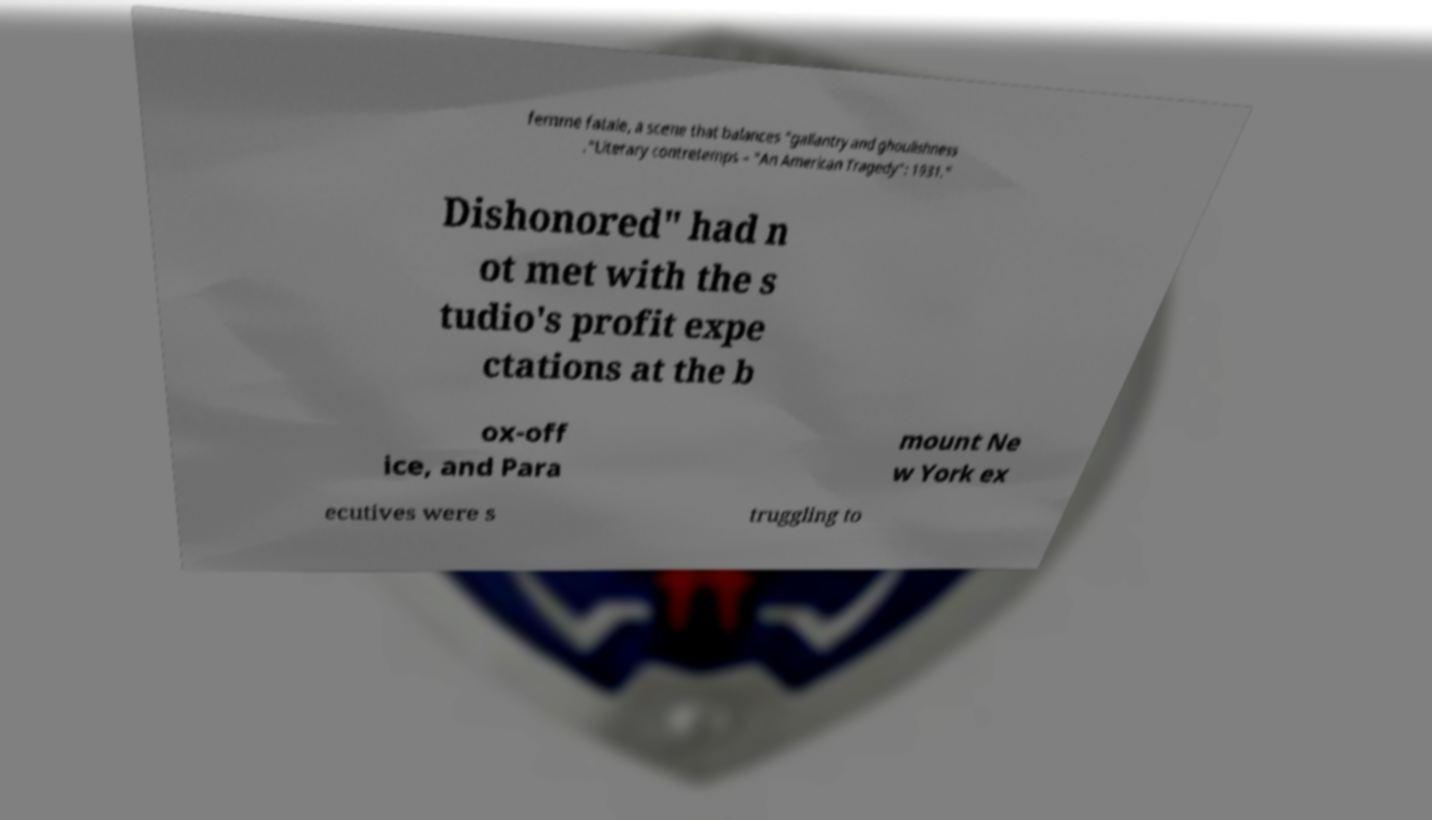Could you assist in decoding the text presented in this image and type it out clearly? femme fatale, a scene that balances "gallantry and ghoulishness ."Literary contretemps – "An American Tragedy": 1931." Dishonored" had n ot met with the s tudio's profit expe ctations at the b ox-off ice, and Para mount Ne w York ex ecutives were s truggling to 